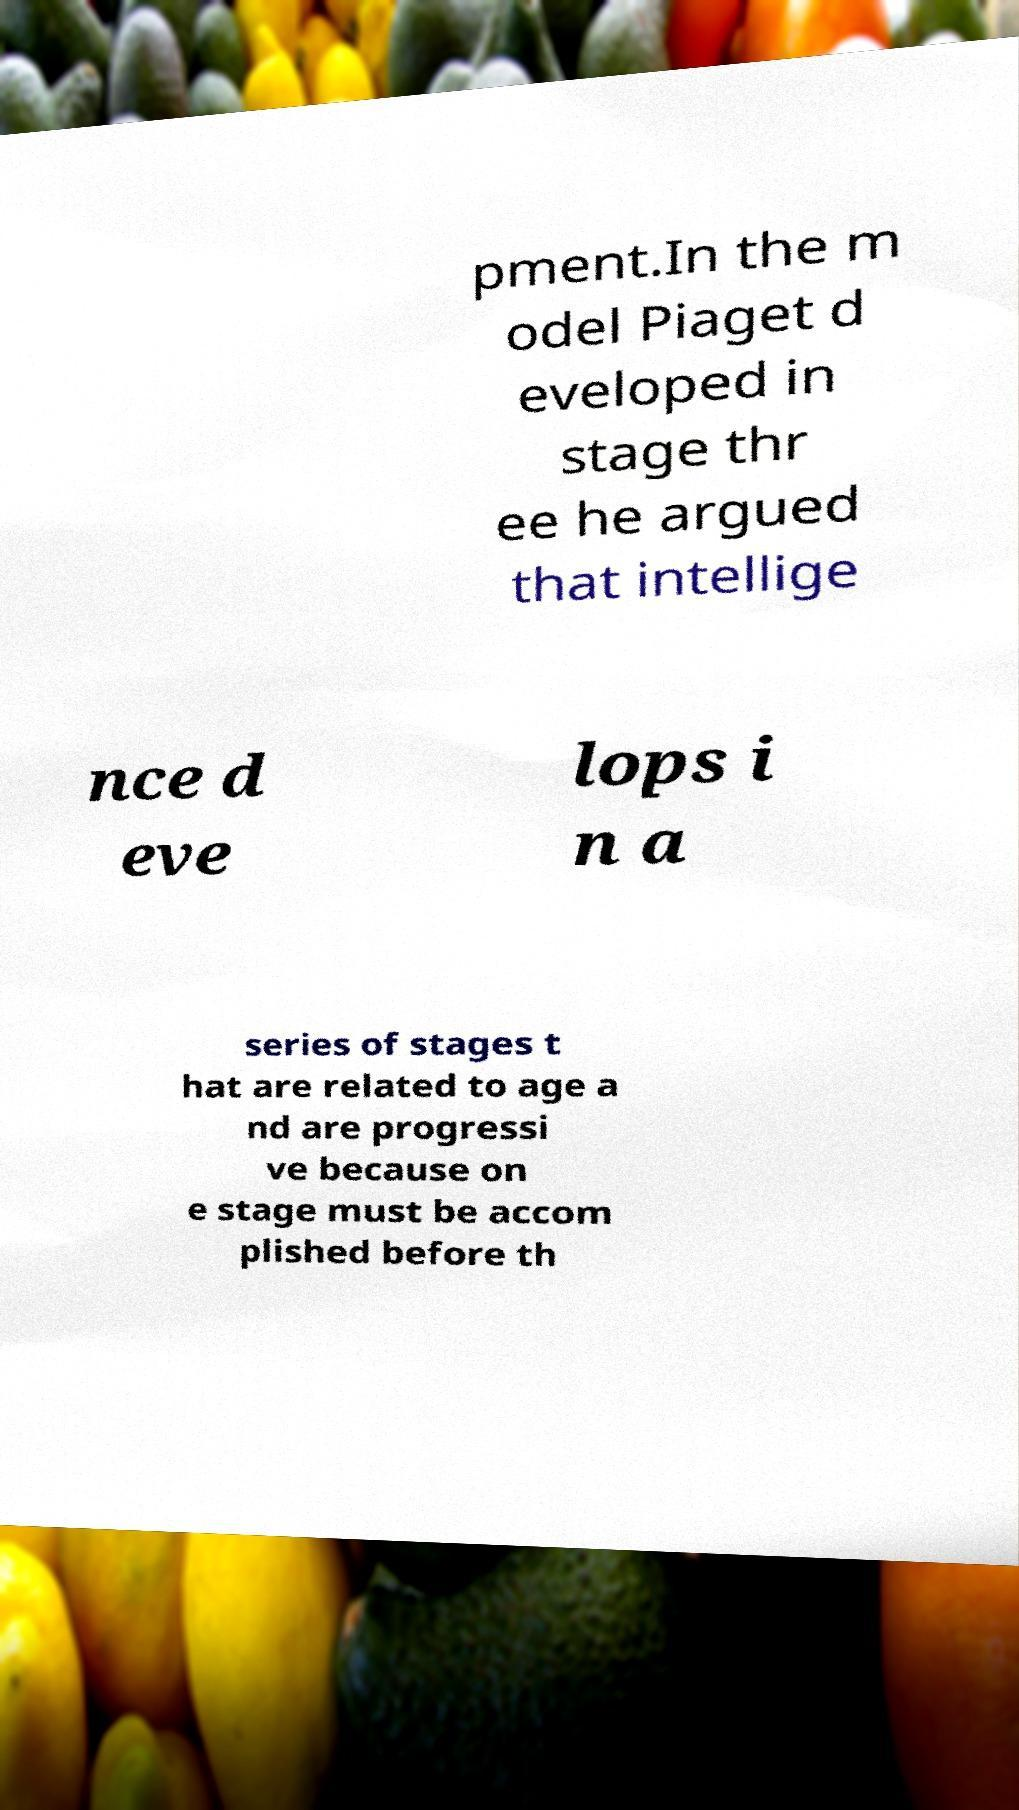Please identify and transcribe the text found in this image. pment.In the m odel Piaget d eveloped in stage thr ee he argued that intellige nce d eve lops i n a series of stages t hat are related to age a nd are progressi ve because on e stage must be accom plished before th 